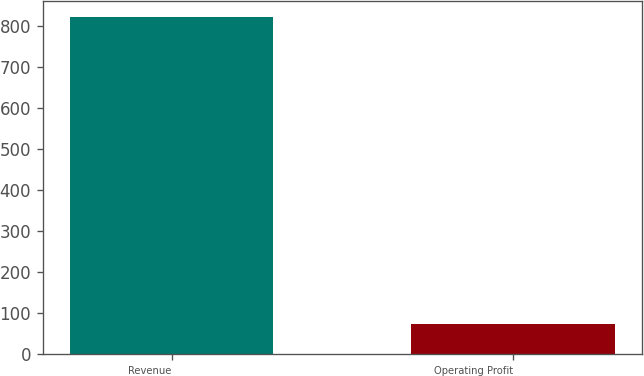Convert chart. <chart><loc_0><loc_0><loc_500><loc_500><bar_chart><fcel>Revenue<fcel>Operating Profit<nl><fcel>822<fcel>72.6<nl></chart> 